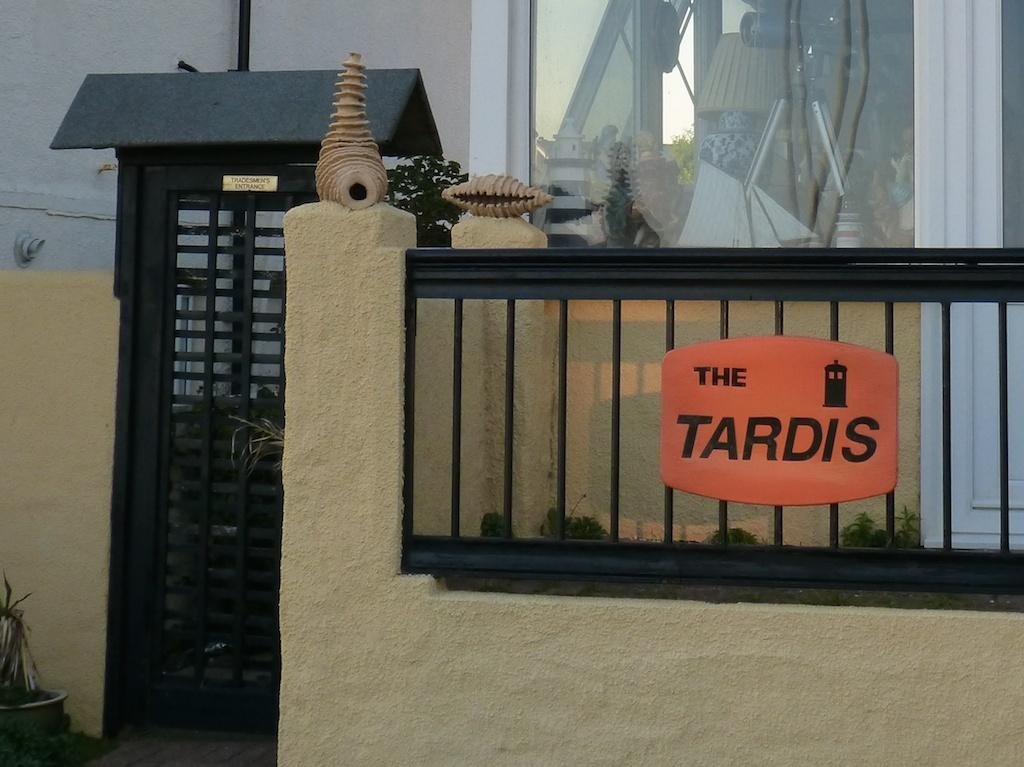What structure can be seen in the image? There is a gate in the image. How is the gate connected to another structure? The gate is attached to a wall. What is located in the middle of the image? There is a board in the middle of the image. Can you see a rat balancing on the hydrant in the image? There is no hydrant or rat present in the image. 